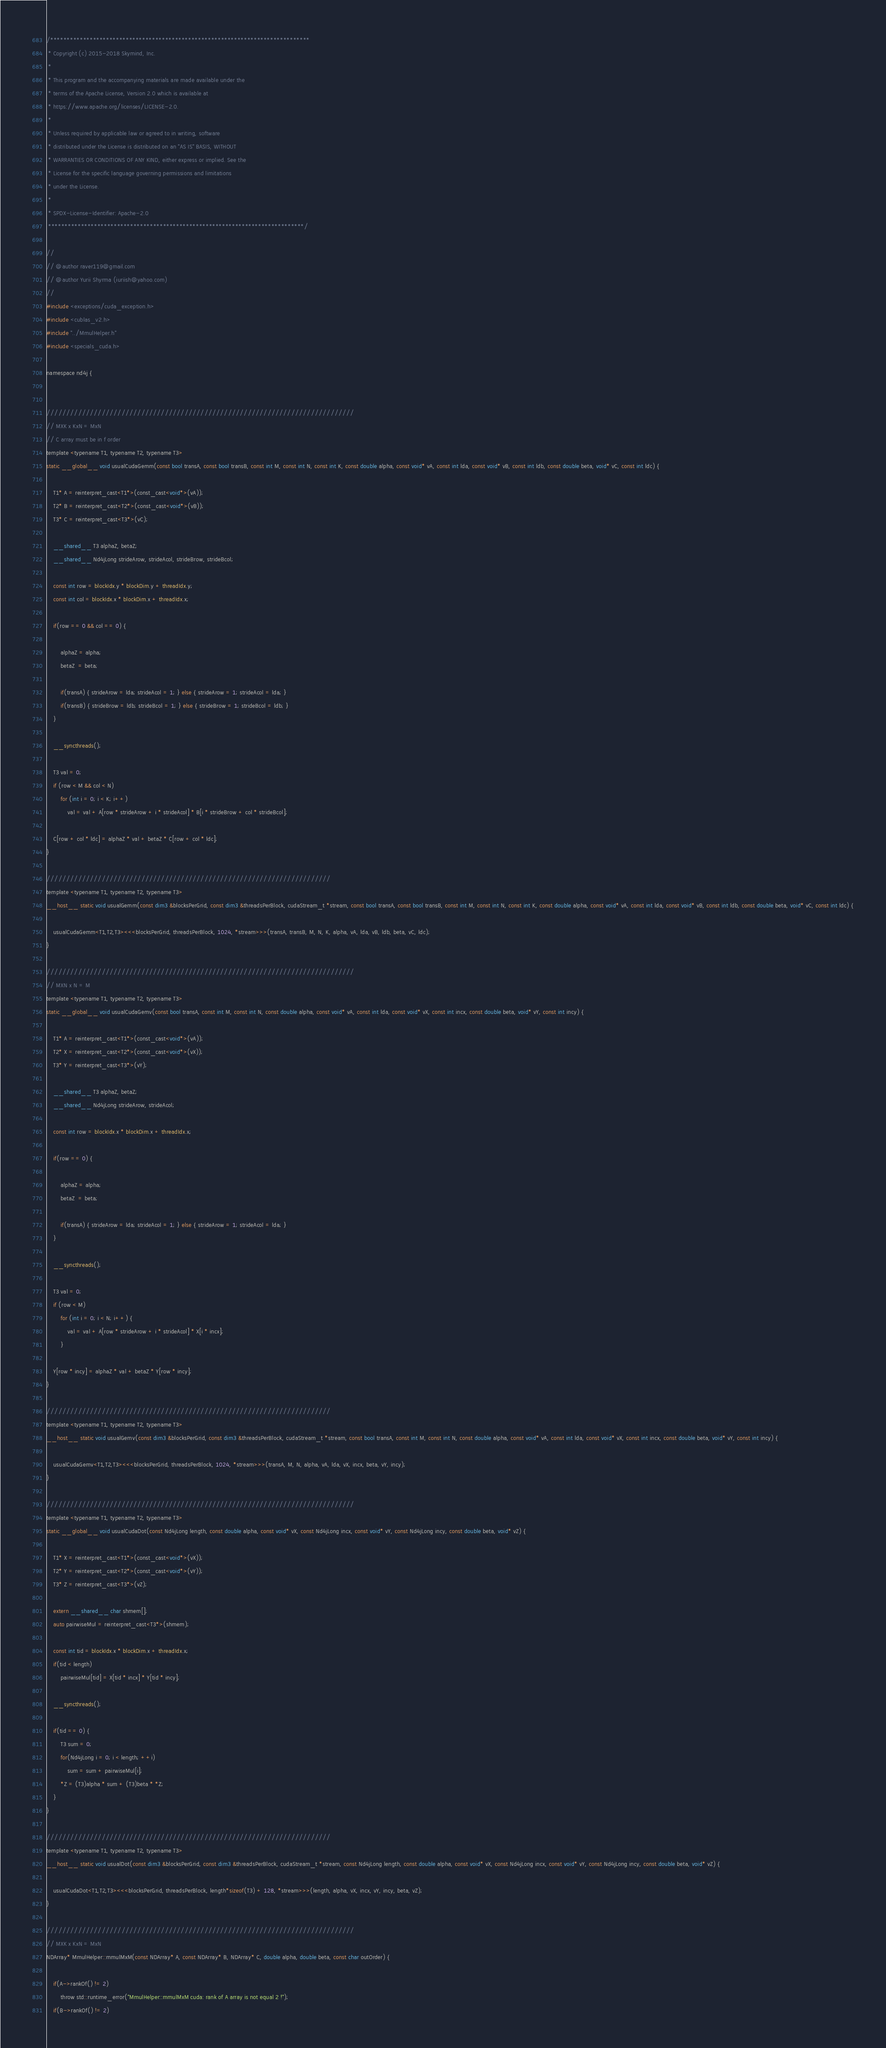Convert code to text. <code><loc_0><loc_0><loc_500><loc_500><_Cuda_>/*******************************************************************************
 * Copyright (c) 2015-2018 Skymind, Inc.
 *
 * This program and the accompanying materials are made available under the
 * terms of the Apache License, Version 2.0 which is available at
 * https://www.apache.org/licenses/LICENSE-2.0.
 *
 * Unless required by applicable law or agreed to in writing, software
 * distributed under the License is distributed on an "AS IS" BASIS, WITHOUT
 * WARRANTIES OR CONDITIONS OF ANY KIND, either express or implied. See the
 * License for the specific language governing permissions and limitations
 * under the License.
 *
 * SPDX-License-Identifier: Apache-2.0
 ******************************************************************************/

//
// @author raver119@gmail.com
// @author Yurii Shyrma (iuriish@yahoo.com)
//
#include <exceptions/cuda_exception.h>
#include <cublas_v2.h>
#include "../MmulHelper.h"
#include <specials_cuda.h>

namespace nd4j {


//////////////////////////////////////////////////////////////////////////////
// MXK x KxN = MxN
// C array must be in f order
template <typename T1, typename T2, typename T3>
static __global__ void usualCudaGemm(const bool transA, const bool transB, const int M, const int N, const int K, const double alpha, const void* vA, const int lda, const void* vB, const int ldb, const double beta, void* vC, const int ldc) {

    T1* A = reinterpret_cast<T1*>(const_cast<void*>(vA));
    T2* B = reinterpret_cast<T2*>(const_cast<void*>(vB));
    T3* C = reinterpret_cast<T3*>(vC);

    __shared__ T3 alphaZ, betaZ;
    __shared__ Nd4jLong strideArow, strideAcol, strideBrow, strideBcol;

    const int row = blockIdx.y * blockDim.y + threadIdx.y;
    const int col = blockIdx.x * blockDim.x + threadIdx.x;

    if(row == 0 && col == 0) {

        alphaZ = alpha;
        betaZ  = beta;

        if(transA) { strideArow = lda; strideAcol = 1; } else { strideArow = 1; strideAcol = lda; }
        if(transB) { strideBrow = ldb; strideBcol = 1; } else { strideBrow = 1; strideBcol = ldb; }
    }

    __syncthreads();

    T3 val = 0;
    if (row < M && col < N)
        for (int i = 0; i < K; i++)
            val = val + A[row * strideArow + i * strideAcol] * B[i * strideBrow + col * strideBcol];

    C[row + col * ldc] = alphaZ * val + betaZ * C[row + col * ldc];
}

////////////////////////////////////////////////////////////////////////
template <typename T1, typename T2, typename T3>
__host__ static void usualGemm(const dim3 &blocksPerGrid, const dim3 &threadsPerBlock, cudaStream_t *stream, const bool transA, const bool transB, const int M, const int N, const int K, const double alpha, const void* vA, const int lda, const void* vB, const int ldb, const double beta, void* vC, const int ldc) {

    usualCudaGemm<T1,T2,T3><<<blocksPerGrid, threadsPerBlock, 1024, *stream>>>(transA, transB, M, N, K, alpha, vA, lda, vB, ldb, beta, vC, ldc);
}

//////////////////////////////////////////////////////////////////////////////
// MXN x N = M
template <typename T1, typename T2, typename T3>
static __global__ void usualCudaGemv(const bool transA, const int M, const int N, const double alpha, const void* vA, const int lda, const void* vX, const int incx, const double beta, void* vY, const int incy) {

    T1* A = reinterpret_cast<T1*>(const_cast<void*>(vA));
    T2* X = reinterpret_cast<T2*>(const_cast<void*>(vX));
    T3* Y = reinterpret_cast<T3*>(vY);

    __shared__ T3 alphaZ, betaZ;
    __shared__ Nd4jLong strideArow, strideAcol;

    const int row = blockIdx.x * blockDim.x + threadIdx.x;

    if(row == 0) {

        alphaZ = alpha;
        betaZ  = beta;

        if(transA) { strideArow = lda; strideAcol = 1; } else { strideArow = 1; strideAcol = lda; }
    }

    __syncthreads();

    T3 val = 0;
    if (row < M)
        for (int i = 0; i < N; i++) {
            val = val + A[row * strideArow + i * strideAcol] * X[i * incx];
        }

    Y[row * incy] = alphaZ * val + betaZ * Y[row * incy];
}

////////////////////////////////////////////////////////////////////////
template <typename T1, typename T2, typename T3>
__host__ static void usualGemv(const dim3 &blocksPerGrid, const dim3 &threadsPerBlock, cudaStream_t *stream, const bool transA, const int M, const int N, const double alpha, const void* vA, const int lda, const void* vX, const int incx, const double beta, void* vY, const int incy) {

    usualCudaGemv<T1,T2,T3><<<blocksPerGrid, threadsPerBlock, 1024, *stream>>>(transA, M, N, alpha, vA, lda, vX, incx, beta, vY, incy);
}

//////////////////////////////////////////////////////////////////////////////
template <typename T1, typename T2, typename T3>
static __global__ void usualCudaDot(const Nd4jLong length, const double alpha, const void* vX, const Nd4jLong incx, const void* vY, const Nd4jLong incy, const double beta, void* vZ) {

    T1* X = reinterpret_cast<T1*>(const_cast<void*>(vX));
    T2* Y = reinterpret_cast<T2*>(const_cast<void*>(vY));
    T3* Z = reinterpret_cast<T3*>(vZ);

    extern __shared__ char shmem[];
    auto pairwiseMul = reinterpret_cast<T3*>(shmem);

    const int tid = blockIdx.x * blockDim.x + threadIdx.x;
    if(tid < length)
        pairwiseMul[tid] = X[tid * incx] * Y[tid * incy];

    __syncthreads();

    if(tid == 0) {
        T3 sum = 0;
        for(Nd4jLong i = 0; i < length; ++i)
            sum = sum + pairwiseMul[i];
        *Z = (T3)alpha * sum + (T3)beta * *Z;
    }
}

////////////////////////////////////////////////////////////////////////
template <typename T1, typename T2, typename T3>
__host__ static void usualDot(const dim3 &blocksPerGrid, const dim3 &threadsPerBlock, cudaStream_t *stream, const Nd4jLong length, const double alpha, const void* vX, const Nd4jLong incx, const void* vY, const Nd4jLong incy, const double beta, void* vZ) {

    usualCudaDot<T1,T2,T3><<<blocksPerGrid, threadsPerBlock, length*sizeof(T3) + 128, *stream>>>(length, alpha, vX, incx, vY, incy, beta, vZ);
}

//////////////////////////////////////////////////////////////////////////////
// MXK x KxN = MxN
NDArray* MmulHelper::mmulMxM(const NDArray* A, const NDArray* B, NDArray* C, double alpha, double beta, const char outOrder) {

    if(A->rankOf() != 2)
        throw std::runtime_error("MmulHelper::mmulMxM cuda: rank of A array is not equal 2 !");
    if(B->rankOf() != 2)</code> 